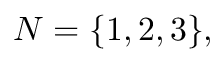Convert formula to latex. <formula><loc_0><loc_0><loc_500><loc_500>N = \{ 1 , 2 , 3 \} ,</formula> 